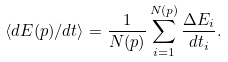<formula> <loc_0><loc_0><loc_500><loc_500>\langle d E ( p ) / d t \rangle = \frac { 1 } { N ( p ) } \sum _ { i = 1 } ^ { N ( p ) } \frac { \Delta E _ { i } } { d t _ { i } } .</formula> 